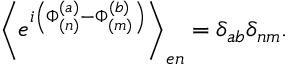Convert formula to latex. <formula><loc_0><loc_0><loc_500><loc_500>\left \langle e ^ { i \left ( \Phi _ { ( n ) } ^ { ( a ) } - \Phi _ { ( m ) } ^ { ( b ) } \right ) } \right \rangle _ { e n } = \delta _ { a b } \delta _ { n m } .</formula> 